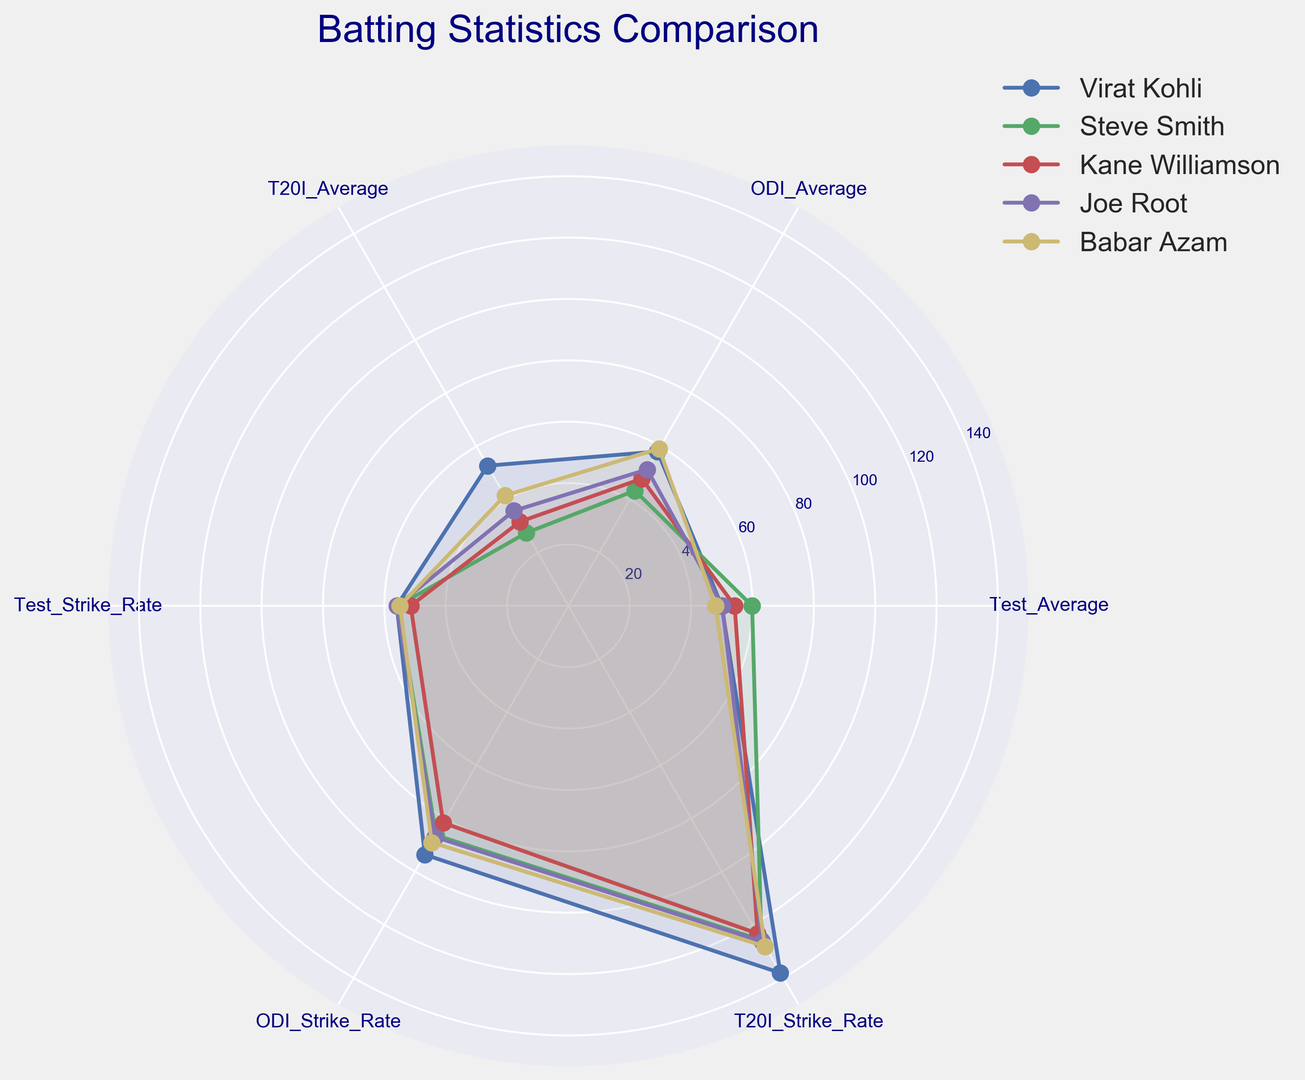Which player has the highest Test strike rate among the top 5 players? Observe the radial point on the Test_Strike_Rate axis where the lines corresponding to the players cross. The highest value will be the furthest from the center.
Answer: David Warner Which player has the most balanced performance across all attributes in the chart? Look for a line that forms a relatively regular shape without extreme peaks or troughs. The player with such a line has a balanced performance.
Answer: Virat Kohli Between Steve Smith and Joe Root, who has a higher Test average? Compare the positions of their lines on the Test_Average axis to see which is further from the center.
Answer: Steve Smith What is the average ODI strike rate for the top 5 players in the chart? Find the positions of the ODI_Strike_Rate points for the five players and calculate the average of these values. Use the formula (Steve Smith + Kane Williamson + Joe Root + Virat Kohli + David Warner) / 5.
Answer: 89.14 Who has the lowest T20I_average among the top 5 players? Examine the radial points on the T20I_Average axis for all players and identify the one closest to the center.
Answer: Steve Smith Among the top 5 players, which one shows the largest difference between their ODI average and T20I average? Calculate the absolute difference between the ODI_Average and T20I_Average for each player and compare them. The player with the highest difference has the largest gap.
Answer: Virat Kohli How does Kane Williamson's Test strike rate compare to Joe Root's Test strike rate? Observe their lines intersecting the Test_Strike_Rate axis and note which one is further from the center.
Answer: Lower Which player has consistently high averages across all three formats? Identify a player whose line is distant from the center on the Test_Average, ODI_Average, and T20I_Average axes.
Answer: Virat Kohli Is there any player whose performance significantly peaks in one format? If so, which format? Look for a player whose line has one significantly higher point compared to others. Determine which axis this peak is on.
Answer: David Warner in T20I Strike Rate 